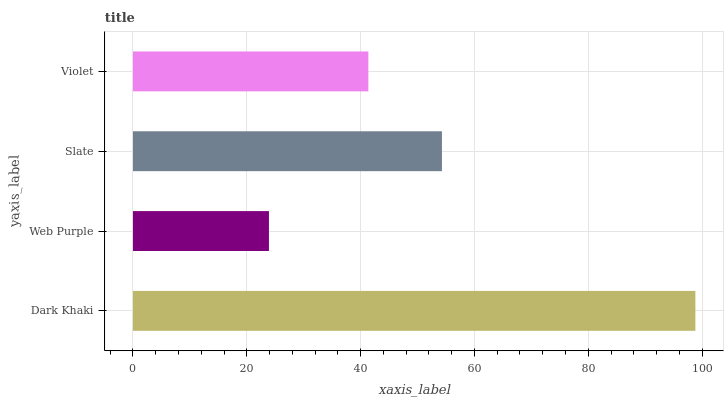Is Web Purple the minimum?
Answer yes or no. Yes. Is Dark Khaki the maximum?
Answer yes or no. Yes. Is Slate the minimum?
Answer yes or no. No. Is Slate the maximum?
Answer yes or no. No. Is Slate greater than Web Purple?
Answer yes or no. Yes. Is Web Purple less than Slate?
Answer yes or no. Yes. Is Web Purple greater than Slate?
Answer yes or no. No. Is Slate less than Web Purple?
Answer yes or no. No. Is Slate the high median?
Answer yes or no. Yes. Is Violet the low median?
Answer yes or no. Yes. Is Web Purple the high median?
Answer yes or no. No. Is Slate the low median?
Answer yes or no. No. 